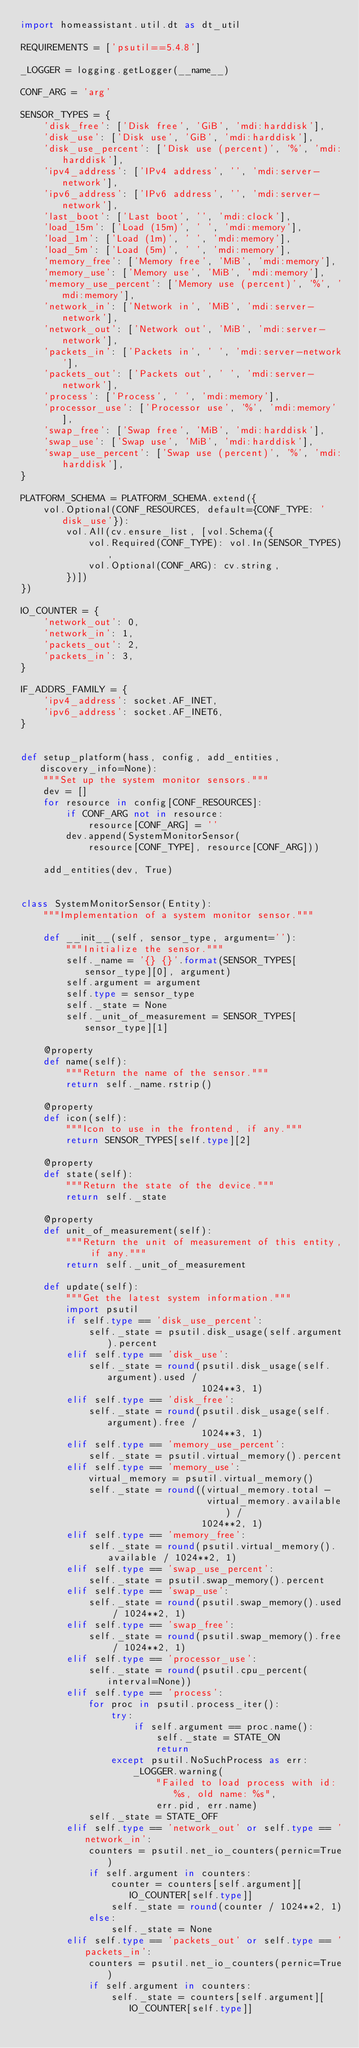<code> <loc_0><loc_0><loc_500><loc_500><_Python_>import homeassistant.util.dt as dt_util

REQUIREMENTS = ['psutil==5.4.8']

_LOGGER = logging.getLogger(__name__)

CONF_ARG = 'arg'

SENSOR_TYPES = {
    'disk_free': ['Disk free', 'GiB', 'mdi:harddisk'],
    'disk_use': ['Disk use', 'GiB', 'mdi:harddisk'],
    'disk_use_percent': ['Disk use (percent)', '%', 'mdi:harddisk'],
    'ipv4_address': ['IPv4 address', '', 'mdi:server-network'],
    'ipv6_address': ['IPv6 address', '', 'mdi:server-network'],
    'last_boot': ['Last boot', '', 'mdi:clock'],
    'load_15m': ['Load (15m)', ' ', 'mdi:memory'],
    'load_1m': ['Load (1m)', ' ', 'mdi:memory'],
    'load_5m': ['Load (5m)', ' ', 'mdi:memory'],
    'memory_free': ['Memory free', 'MiB', 'mdi:memory'],
    'memory_use': ['Memory use', 'MiB', 'mdi:memory'],
    'memory_use_percent': ['Memory use (percent)', '%', 'mdi:memory'],
    'network_in': ['Network in', 'MiB', 'mdi:server-network'],
    'network_out': ['Network out', 'MiB', 'mdi:server-network'],
    'packets_in': ['Packets in', ' ', 'mdi:server-network'],
    'packets_out': ['Packets out', ' ', 'mdi:server-network'],
    'process': ['Process', ' ', 'mdi:memory'],
    'processor_use': ['Processor use', '%', 'mdi:memory'],
    'swap_free': ['Swap free', 'MiB', 'mdi:harddisk'],
    'swap_use': ['Swap use', 'MiB', 'mdi:harddisk'],
    'swap_use_percent': ['Swap use (percent)', '%', 'mdi:harddisk'],
}

PLATFORM_SCHEMA = PLATFORM_SCHEMA.extend({
    vol.Optional(CONF_RESOURCES, default={CONF_TYPE: 'disk_use'}):
        vol.All(cv.ensure_list, [vol.Schema({
            vol.Required(CONF_TYPE): vol.In(SENSOR_TYPES),
            vol.Optional(CONF_ARG): cv.string,
        })])
})

IO_COUNTER = {
    'network_out': 0,
    'network_in': 1,
    'packets_out': 2,
    'packets_in': 3,
}

IF_ADDRS_FAMILY = {
    'ipv4_address': socket.AF_INET,
    'ipv6_address': socket.AF_INET6,
}


def setup_platform(hass, config, add_entities, discovery_info=None):
    """Set up the system monitor sensors."""
    dev = []
    for resource in config[CONF_RESOURCES]:
        if CONF_ARG not in resource:
            resource[CONF_ARG] = ''
        dev.append(SystemMonitorSensor(
            resource[CONF_TYPE], resource[CONF_ARG]))

    add_entities(dev, True)


class SystemMonitorSensor(Entity):
    """Implementation of a system monitor sensor."""

    def __init__(self, sensor_type, argument=''):
        """Initialize the sensor."""
        self._name = '{} {}'.format(SENSOR_TYPES[sensor_type][0], argument)
        self.argument = argument
        self.type = sensor_type
        self._state = None
        self._unit_of_measurement = SENSOR_TYPES[sensor_type][1]

    @property
    def name(self):
        """Return the name of the sensor."""
        return self._name.rstrip()

    @property
    def icon(self):
        """Icon to use in the frontend, if any."""
        return SENSOR_TYPES[self.type][2]

    @property
    def state(self):
        """Return the state of the device."""
        return self._state

    @property
    def unit_of_measurement(self):
        """Return the unit of measurement of this entity, if any."""
        return self._unit_of_measurement

    def update(self):
        """Get the latest system information."""
        import psutil
        if self.type == 'disk_use_percent':
            self._state = psutil.disk_usage(self.argument).percent
        elif self.type == 'disk_use':
            self._state = round(psutil.disk_usage(self.argument).used /
                                1024**3, 1)
        elif self.type == 'disk_free':
            self._state = round(psutil.disk_usage(self.argument).free /
                                1024**3, 1)
        elif self.type == 'memory_use_percent':
            self._state = psutil.virtual_memory().percent
        elif self.type == 'memory_use':
            virtual_memory = psutil.virtual_memory()
            self._state = round((virtual_memory.total -
                                 virtual_memory.available) /
                                1024**2, 1)
        elif self.type == 'memory_free':
            self._state = round(psutil.virtual_memory().available / 1024**2, 1)
        elif self.type == 'swap_use_percent':
            self._state = psutil.swap_memory().percent
        elif self.type == 'swap_use':
            self._state = round(psutil.swap_memory().used / 1024**2, 1)
        elif self.type == 'swap_free':
            self._state = round(psutil.swap_memory().free / 1024**2, 1)
        elif self.type == 'processor_use':
            self._state = round(psutil.cpu_percent(interval=None))
        elif self.type == 'process':
            for proc in psutil.process_iter():
                try:
                    if self.argument == proc.name():
                        self._state = STATE_ON
                        return
                except psutil.NoSuchProcess as err:
                    _LOGGER.warning(
                        "Failed to load process with id: %s, old name: %s",
                        err.pid, err.name)
            self._state = STATE_OFF
        elif self.type == 'network_out' or self.type == 'network_in':
            counters = psutil.net_io_counters(pernic=True)
            if self.argument in counters:
                counter = counters[self.argument][IO_COUNTER[self.type]]
                self._state = round(counter / 1024**2, 1)
            else:
                self._state = None
        elif self.type == 'packets_out' or self.type == 'packets_in':
            counters = psutil.net_io_counters(pernic=True)
            if self.argument in counters:
                self._state = counters[self.argument][IO_COUNTER[self.type]]</code> 